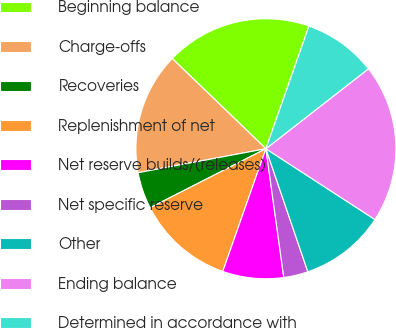Convert chart to OTSL. <chart><loc_0><loc_0><loc_500><loc_500><pie_chart><fcel>Beginning balance<fcel>Charge-offs<fcel>Recoveries<fcel>Replenishment of net<fcel>Net reserve builds/(releases)<fcel>Net specific reserve<fcel>Other<fcel>Ending balance<fcel>Determined in accordance with<nl><fcel>18.18%<fcel>15.15%<fcel>4.55%<fcel>12.12%<fcel>7.58%<fcel>3.03%<fcel>10.61%<fcel>19.7%<fcel>9.09%<nl></chart> 